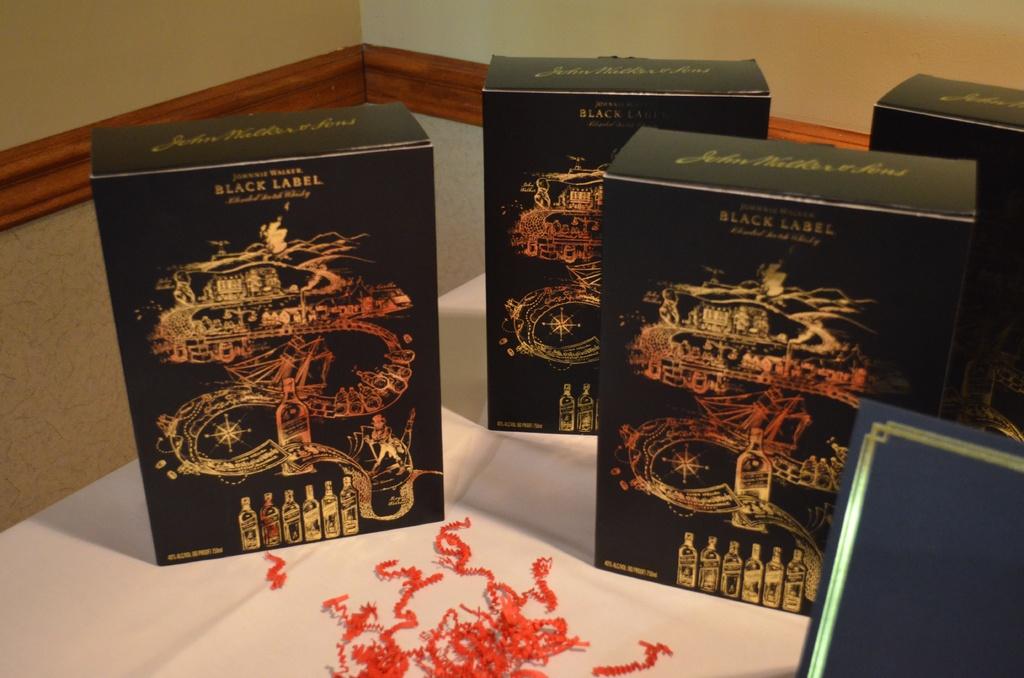What is the text written on those boxes?
Ensure brevity in your answer.  Black label. 